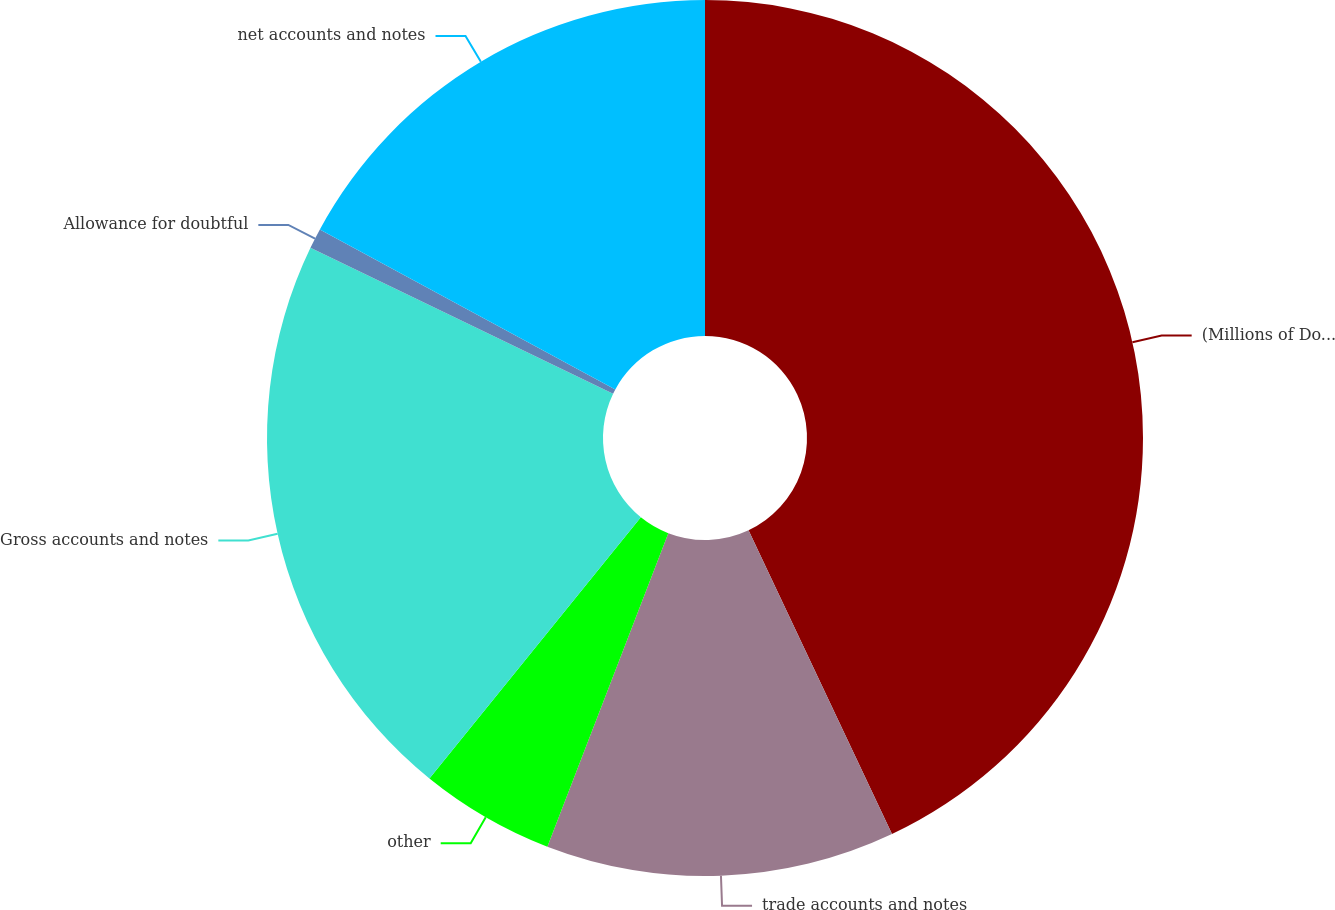<chart> <loc_0><loc_0><loc_500><loc_500><pie_chart><fcel>(Millions of Dollars)<fcel>trade accounts and notes<fcel>other<fcel>Gross accounts and notes<fcel>Allowance for doubtful<fcel>net accounts and notes<nl><fcel>42.98%<fcel>12.88%<fcel>4.97%<fcel>21.32%<fcel>0.75%<fcel>17.1%<nl></chart> 